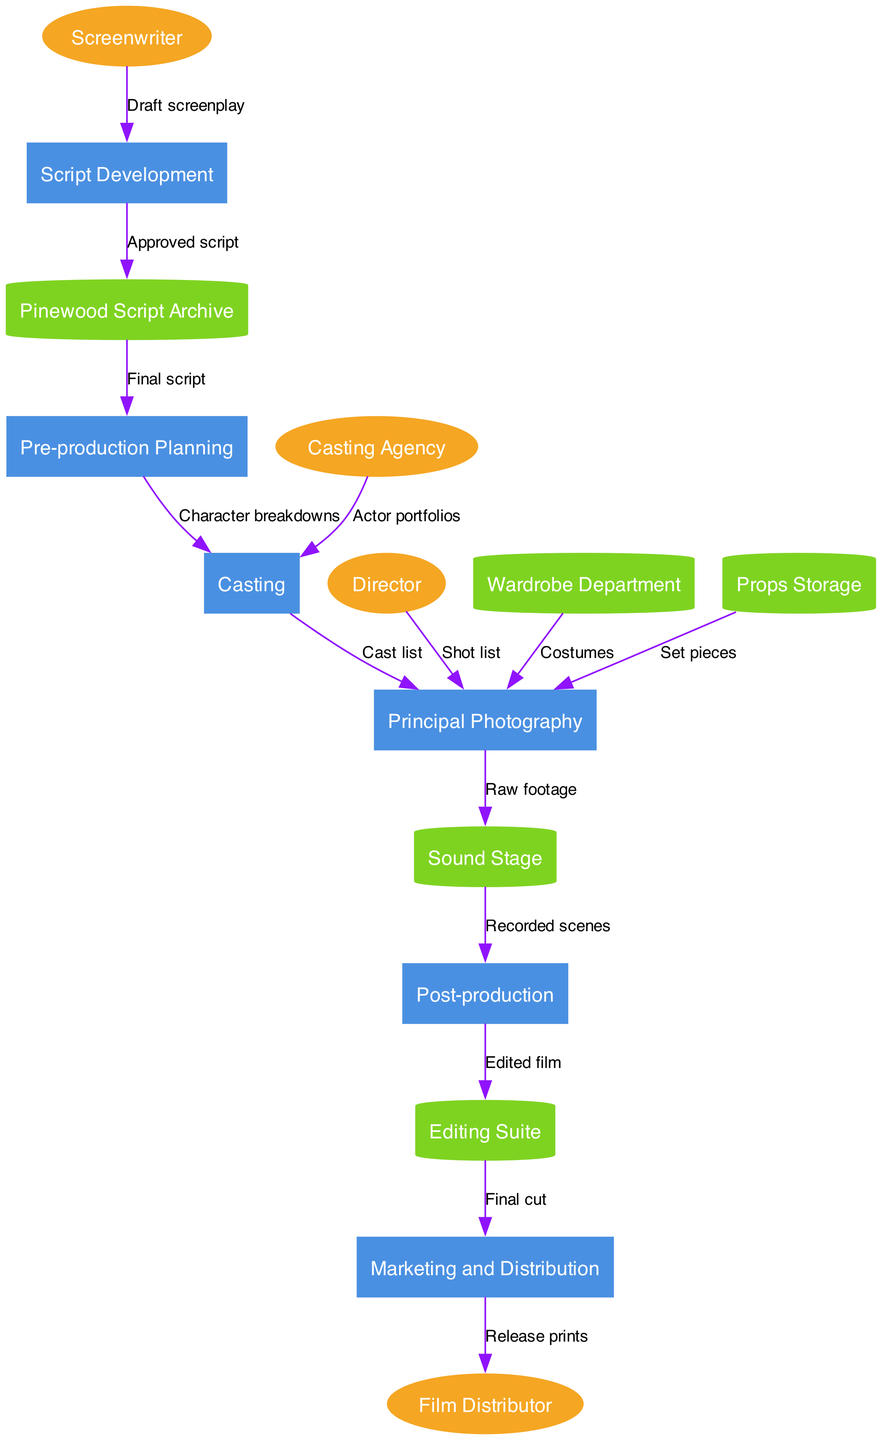What are the external entities in the diagram? The external entities are the actors outside the main processes of the workflow that interact with the system. In this diagram, they are specified separately and include the Screenwriter, Director, Casting Agency, and Film Distributor. Thus, there are four external entities.
Answer: Screenwriter, Director, Casting Agency, Film Distributor What is the first process in the workflow? Processes are a series of steps in the production workflow, and the first one is explicitly listed in the diagram. It starts with Script Development, which comes directly after the external entity, Screenwriter.
Answer: Script Development How many data stores are present in the diagram? Data stores are identified as places where data is kept. In this diagram, there are five distinct data stores mentioned: Pinewood Script Archive, Wardrobe Department, Props Storage, Editing Suite, and Sound Stage. Thus, the count is straightforward.
Answer: Five What type of relationship exists between Principal Photography and Sound Stage? The relationship can be extracted by following the data flow indicated in the diagram, which shows that the output from Principal Photography is Raw footage, and it flows into Sound Stage. This signifies that the Principal Photography generates raw footage that is recorded in the Sound Stage.
Answer: Flow What happens to the final cut of the film after the Editing Suite? The final cut of the film is produced in the Editing Suite and then moves on to the Marketing and Distribution stage. This shows that the completed film after editing is passed along for marketing and eventual distribution, indicating progression to the next major activity.
Answer: Marketing and Distribution What is the data flow from Pre-production Planning to Casting? The data flow between these processes involves the transfer of Character breakdowns from Pre-production Planning to Casting. This flow means that the details about the characters are provided to help in selecting the appropriate cast for the film.
Answer: Character breakdowns How does the film distributor receive the release prints? According to the data flow, the Marketing and Distribution process sends the release prints to the Film Distributor. This indicates that once the marketing phase is complete and prints are made, they are sent directly to the distributor for broader release.
Answer: Marketing and Distribution What type of node connects the Casting Agency to Casting? The connection from the Casting Agency to Casting is represented as a data flow labeled Actor portfolios. This type of connection shows that actor portfolios are input into the Casting process to assist in the selection of actors.
Answer: Data flow 